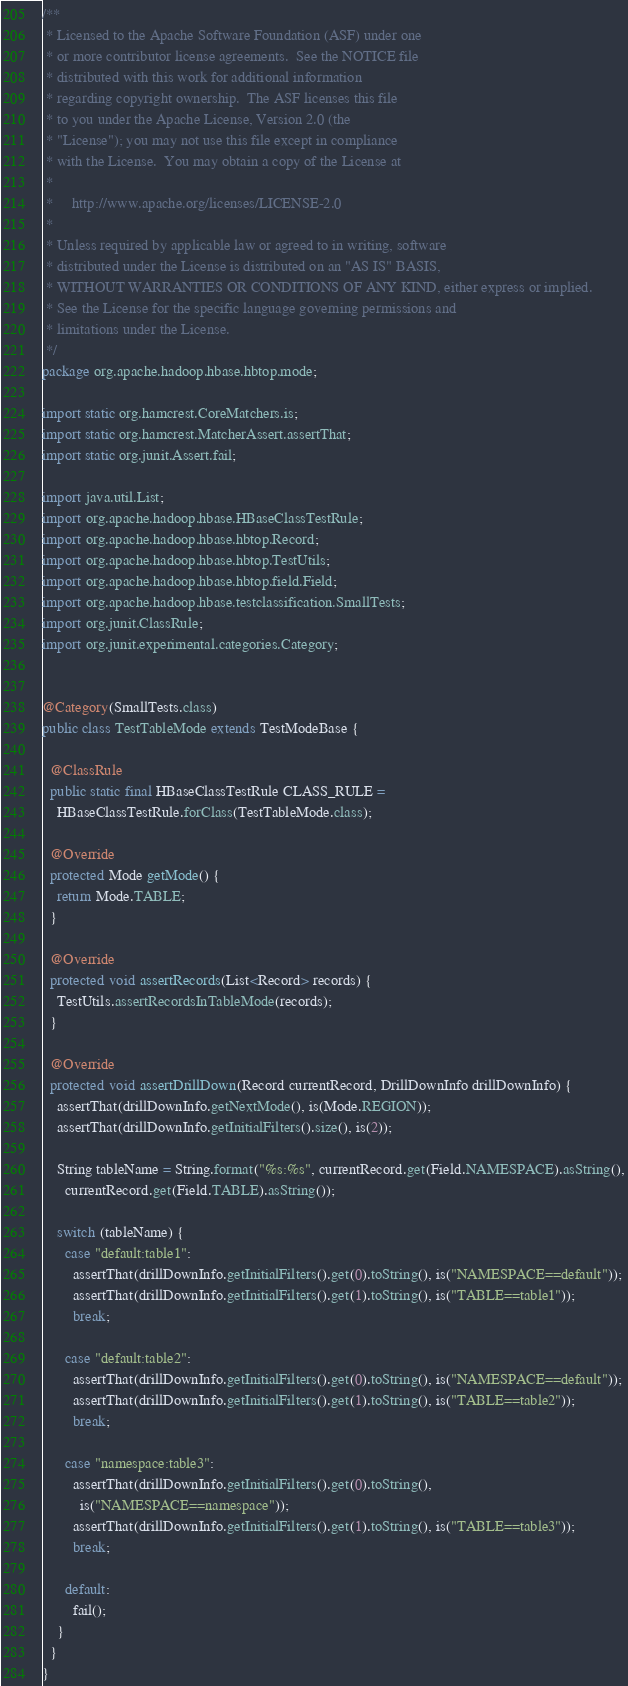<code> <loc_0><loc_0><loc_500><loc_500><_Java_>/**
 * Licensed to the Apache Software Foundation (ASF) under one
 * or more contributor license agreements.  See the NOTICE file
 * distributed with this work for additional information
 * regarding copyright ownership.  The ASF licenses this file
 * to you under the Apache License, Version 2.0 (the
 * "License"); you may not use this file except in compliance
 * with the License.  You may obtain a copy of the License at
 *
 *     http://www.apache.org/licenses/LICENSE-2.0
 *
 * Unless required by applicable law or agreed to in writing, software
 * distributed under the License is distributed on an "AS IS" BASIS,
 * WITHOUT WARRANTIES OR CONDITIONS OF ANY KIND, either express or implied.
 * See the License for the specific language governing permissions and
 * limitations under the License.
 */
package org.apache.hadoop.hbase.hbtop.mode;

import static org.hamcrest.CoreMatchers.is;
import static org.hamcrest.MatcherAssert.assertThat;
import static org.junit.Assert.fail;

import java.util.List;
import org.apache.hadoop.hbase.HBaseClassTestRule;
import org.apache.hadoop.hbase.hbtop.Record;
import org.apache.hadoop.hbase.hbtop.TestUtils;
import org.apache.hadoop.hbase.hbtop.field.Field;
import org.apache.hadoop.hbase.testclassification.SmallTests;
import org.junit.ClassRule;
import org.junit.experimental.categories.Category;


@Category(SmallTests.class)
public class TestTableMode extends TestModeBase {

  @ClassRule
  public static final HBaseClassTestRule CLASS_RULE =
    HBaseClassTestRule.forClass(TestTableMode.class);

  @Override
  protected Mode getMode() {
    return Mode.TABLE;
  }

  @Override
  protected void assertRecords(List<Record> records) {
    TestUtils.assertRecordsInTableMode(records);
  }

  @Override
  protected void assertDrillDown(Record currentRecord, DrillDownInfo drillDownInfo) {
    assertThat(drillDownInfo.getNextMode(), is(Mode.REGION));
    assertThat(drillDownInfo.getInitialFilters().size(), is(2));

    String tableName = String.format("%s:%s", currentRecord.get(Field.NAMESPACE).asString(),
      currentRecord.get(Field.TABLE).asString());

    switch (tableName) {
      case "default:table1":
        assertThat(drillDownInfo.getInitialFilters().get(0).toString(), is("NAMESPACE==default"));
        assertThat(drillDownInfo.getInitialFilters().get(1).toString(), is("TABLE==table1"));
        break;

      case "default:table2":
        assertThat(drillDownInfo.getInitialFilters().get(0).toString(), is("NAMESPACE==default"));
        assertThat(drillDownInfo.getInitialFilters().get(1).toString(), is("TABLE==table2"));
        break;

      case "namespace:table3":
        assertThat(drillDownInfo.getInitialFilters().get(0).toString(),
          is("NAMESPACE==namespace"));
        assertThat(drillDownInfo.getInitialFilters().get(1).toString(), is("TABLE==table3"));
        break;

      default:
        fail();
    }
  }
}
</code> 